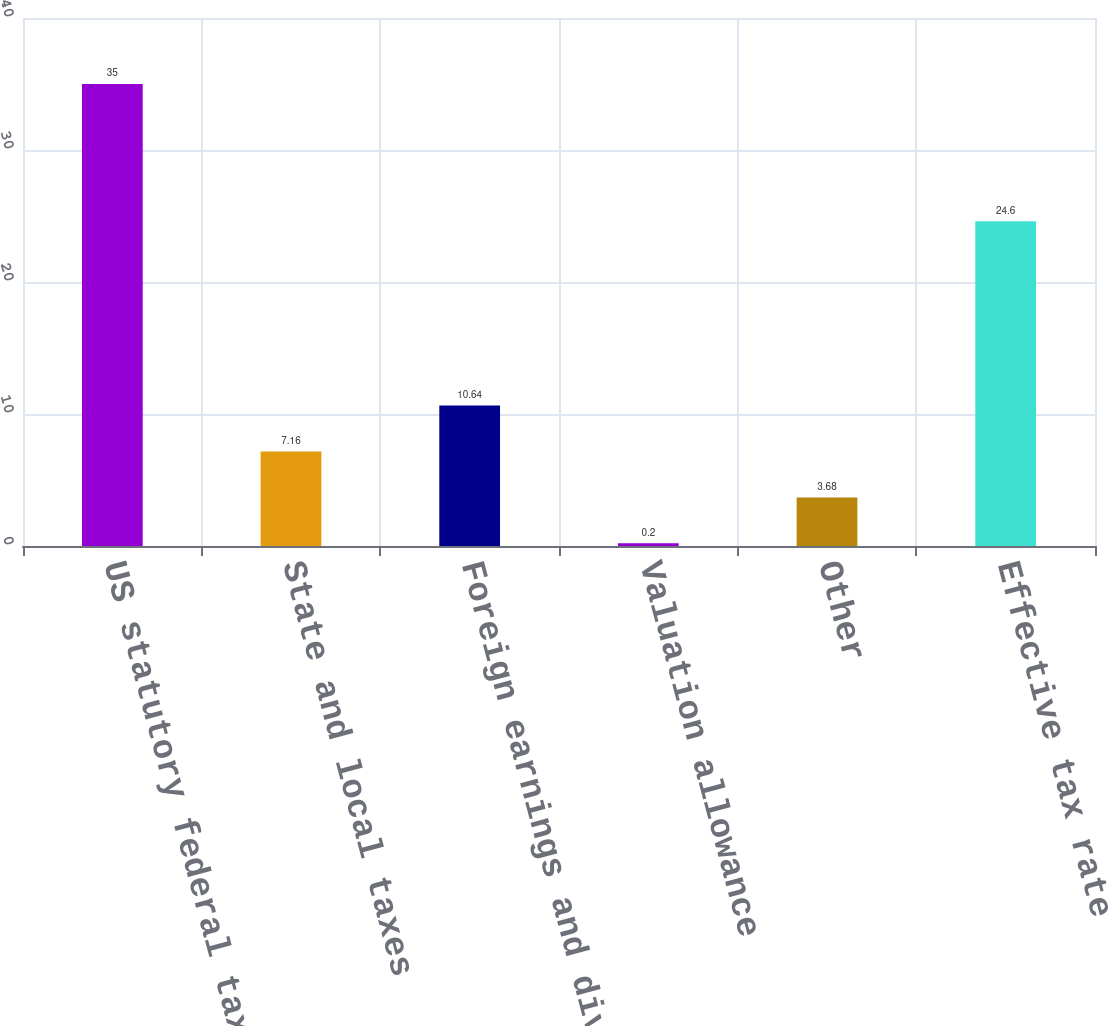Convert chart to OTSL. <chart><loc_0><loc_0><loc_500><loc_500><bar_chart><fcel>US statutory federal tax rate<fcel>State and local taxes<fcel>Foreign earnings and dividends<fcel>Valuation allowance<fcel>Other<fcel>Effective tax rate<nl><fcel>35<fcel>7.16<fcel>10.64<fcel>0.2<fcel>3.68<fcel>24.6<nl></chart> 